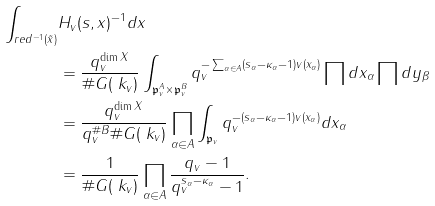Convert formula to latex. <formula><loc_0><loc_0><loc_500><loc_500>\int _ { r e d ^ { - 1 } ( \tilde { x } ) } & H _ { v } ( { s } , x ) ^ { - 1 } d x \\ & = \frac { q _ { v } ^ { \dim X } } { \# G ( \ k _ { v } ) } \int _ { \mathfrak { p } _ { v } ^ { A } \times \mathfrak { p } _ { v } ^ { B } } q _ { v } ^ { - \sum _ { \alpha \in A } ( s _ { \alpha } - \kappa _ { \alpha } - 1 ) v ( x _ { \alpha } ) } \prod d x _ { \alpha } \prod d y _ { \beta } \\ & = \frac { q _ { v } ^ { \dim X } } { q _ { v } ^ { \# B } \# G ( \ k _ { v } ) } \prod _ { \alpha \in A } \int _ { \mathfrak { p } _ { v } } q _ { v } ^ { - ( s _ { \alpha } - \kappa _ { \alpha } - 1 ) v ( x _ { \alpha } ) } d x _ { \alpha } \\ & = \frac { 1 } { \# G ( \ k _ { v } ) } \prod _ { \alpha \in A } \frac { q _ { v } - 1 } { q _ { v } ^ { s _ { \alpha } - \kappa _ { \alpha } } - 1 } .</formula> 